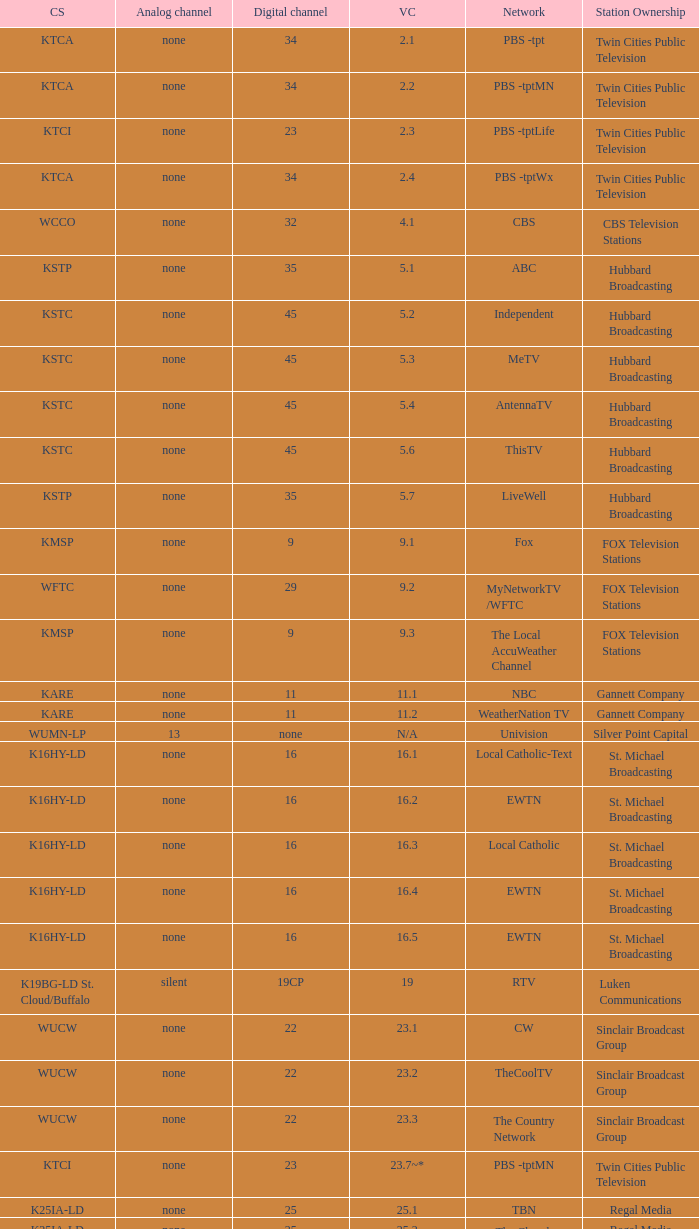Digital channel of 32 belongs to what analog channel? None. 